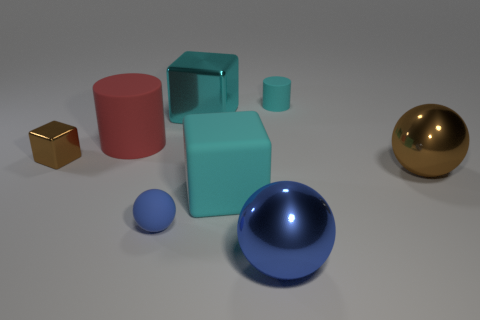Add 2 large brown objects. How many objects exist? 10 Subtract all cubes. How many objects are left? 5 Subtract all big things. Subtract all brown objects. How many objects are left? 1 Add 3 small brown cubes. How many small brown cubes are left? 4 Add 3 green shiny things. How many green shiny things exist? 3 Subtract 1 brown balls. How many objects are left? 7 